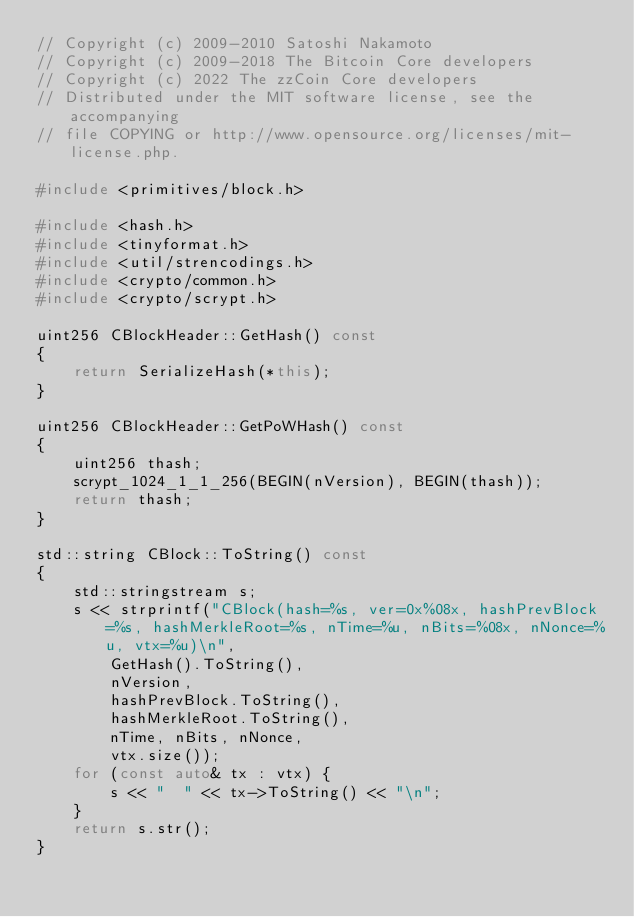<code> <loc_0><loc_0><loc_500><loc_500><_C++_>// Copyright (c) 2009-2010 Satoshi Nakamoto
// Copyright (c) 2009-2018 The Bitcoin Core developers
// Copyright (c) 2022 The zzCoin Core developers
// Distributed under the MIT software license, see the accompanying
// file COPYING or http://www.opensource.org/licenses/mit-license.php.

#include <primitives/block.h>

#include <hash.h>
#include <tinyformat.h>
#include <util/strencodings.h>
#include <crypto/common.h>
#include <crypto/scrypt.h>

uint256 CBlockHeader::GetHash() const
{
    return SerializeHash(*this);
}

uint256 CBlockHeader::GetPoWHash() const
{
    uint256 thash;
    scrypt_1024_1_1_256(BEGIN(nVersion), BEGIN(thash));
    return thash;
}

std::string CBlock::ToString() const
{
    std::stringstream s;
    s << strprintf("CBlock(hash=%s, ver=0x%08x, hashPrevBlock=%s, hashMerkleRoot=%s, nTime=%u, nBits=%08x, nNonce=%u, vtx=%u)\n",
        GetHash().ToString(),
        nVersion,
        hashPrevBlock.ToString(),
        hashMerkleRoot.ToString(),
        nTime, nBits, nNonce,
        vtx.size());
    for (const auto& tx : vtx) {
        s << "  " << tx->ToString() << "\n";
    }
    return s.str();
}
</code> 